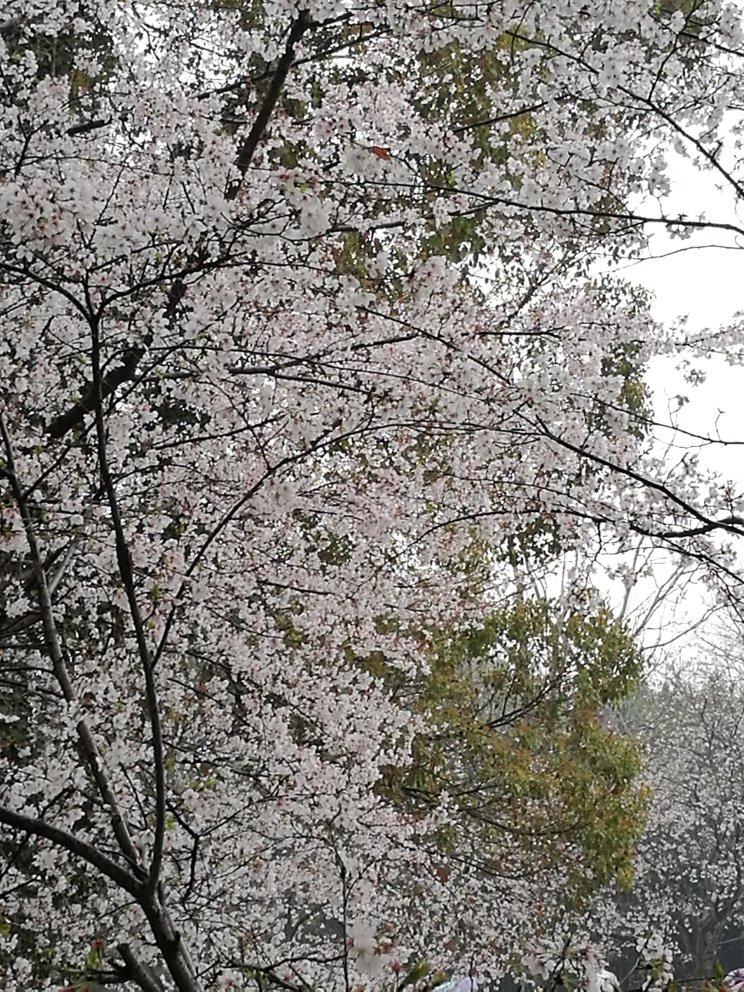Could you suggest an ideal setting or use for this image? This serene image of cherry blossoms might be well-suited as a calming piece of wall art in spaces meant for relaxation or meditation. It could also serve as an illustrative background for poetry or literary works that celebrate nature, growth, and the fleeting nature of life symbolized by the brief but beautiful cherry blossom season. 